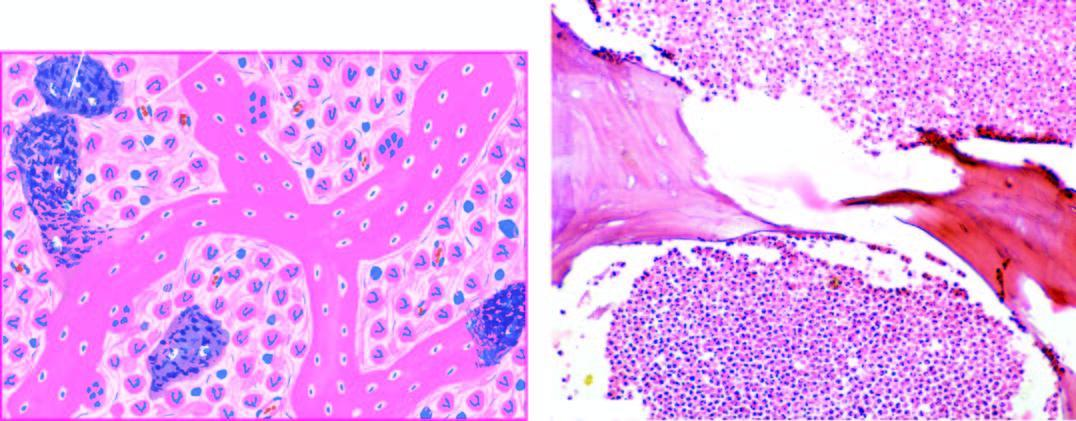what does histologic appearance show?
Answer the question using a single word or phrase. Necrotic bone and extensive purulent inflammatory exudate 